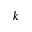Convert formula to latex. <formula><loc_0><loc_0><loc_500><loc_500>k</formula> 